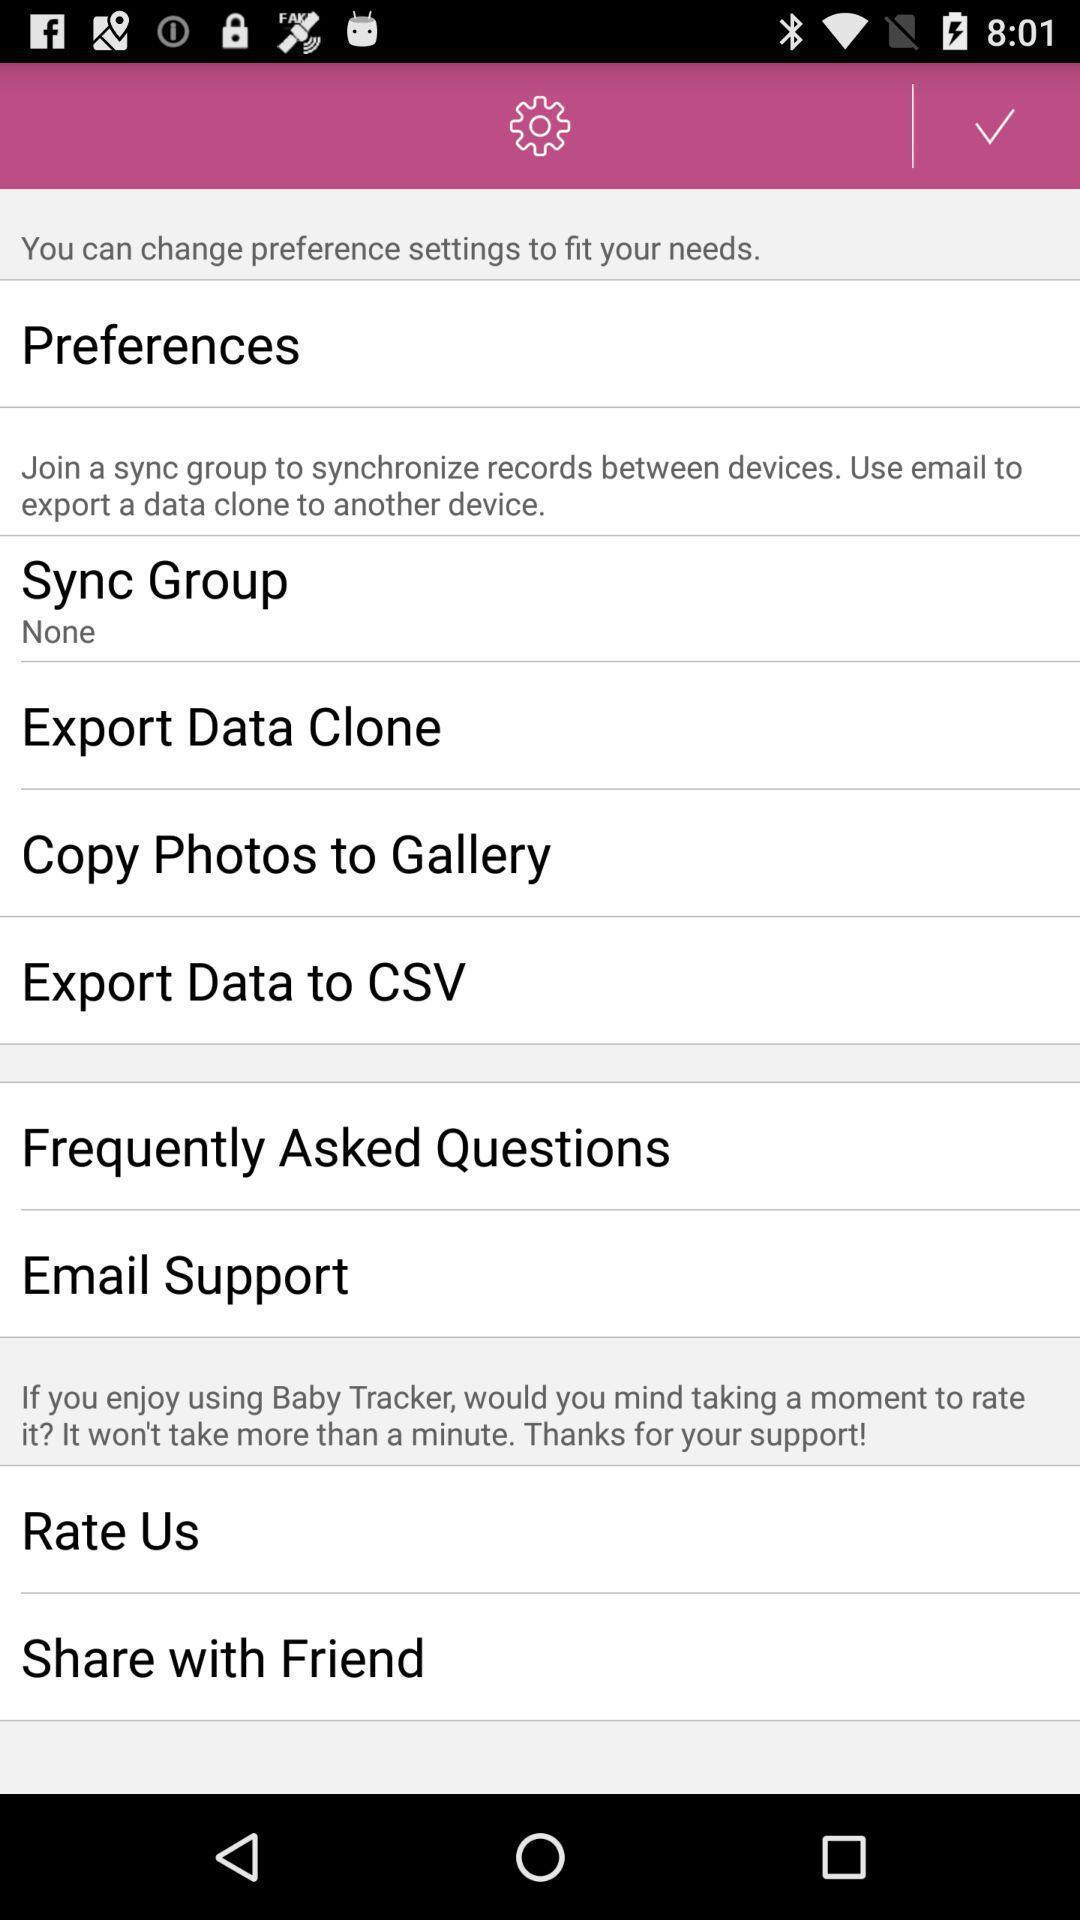Provide a description of this screenshot. Screen displaying multiple options in settings page. 